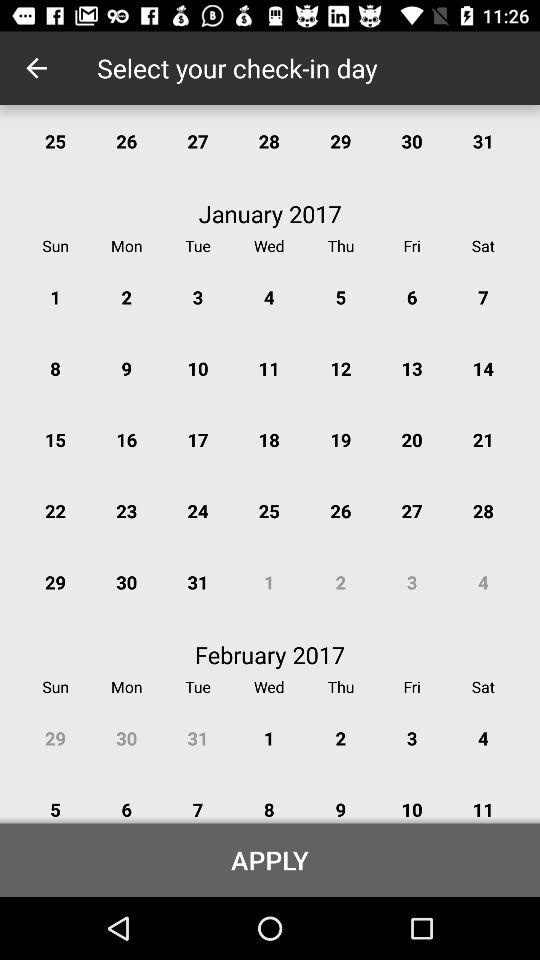Which day is selected for check-in?
When the provided information is insufficient, respond with <no answer>. <no answer> 